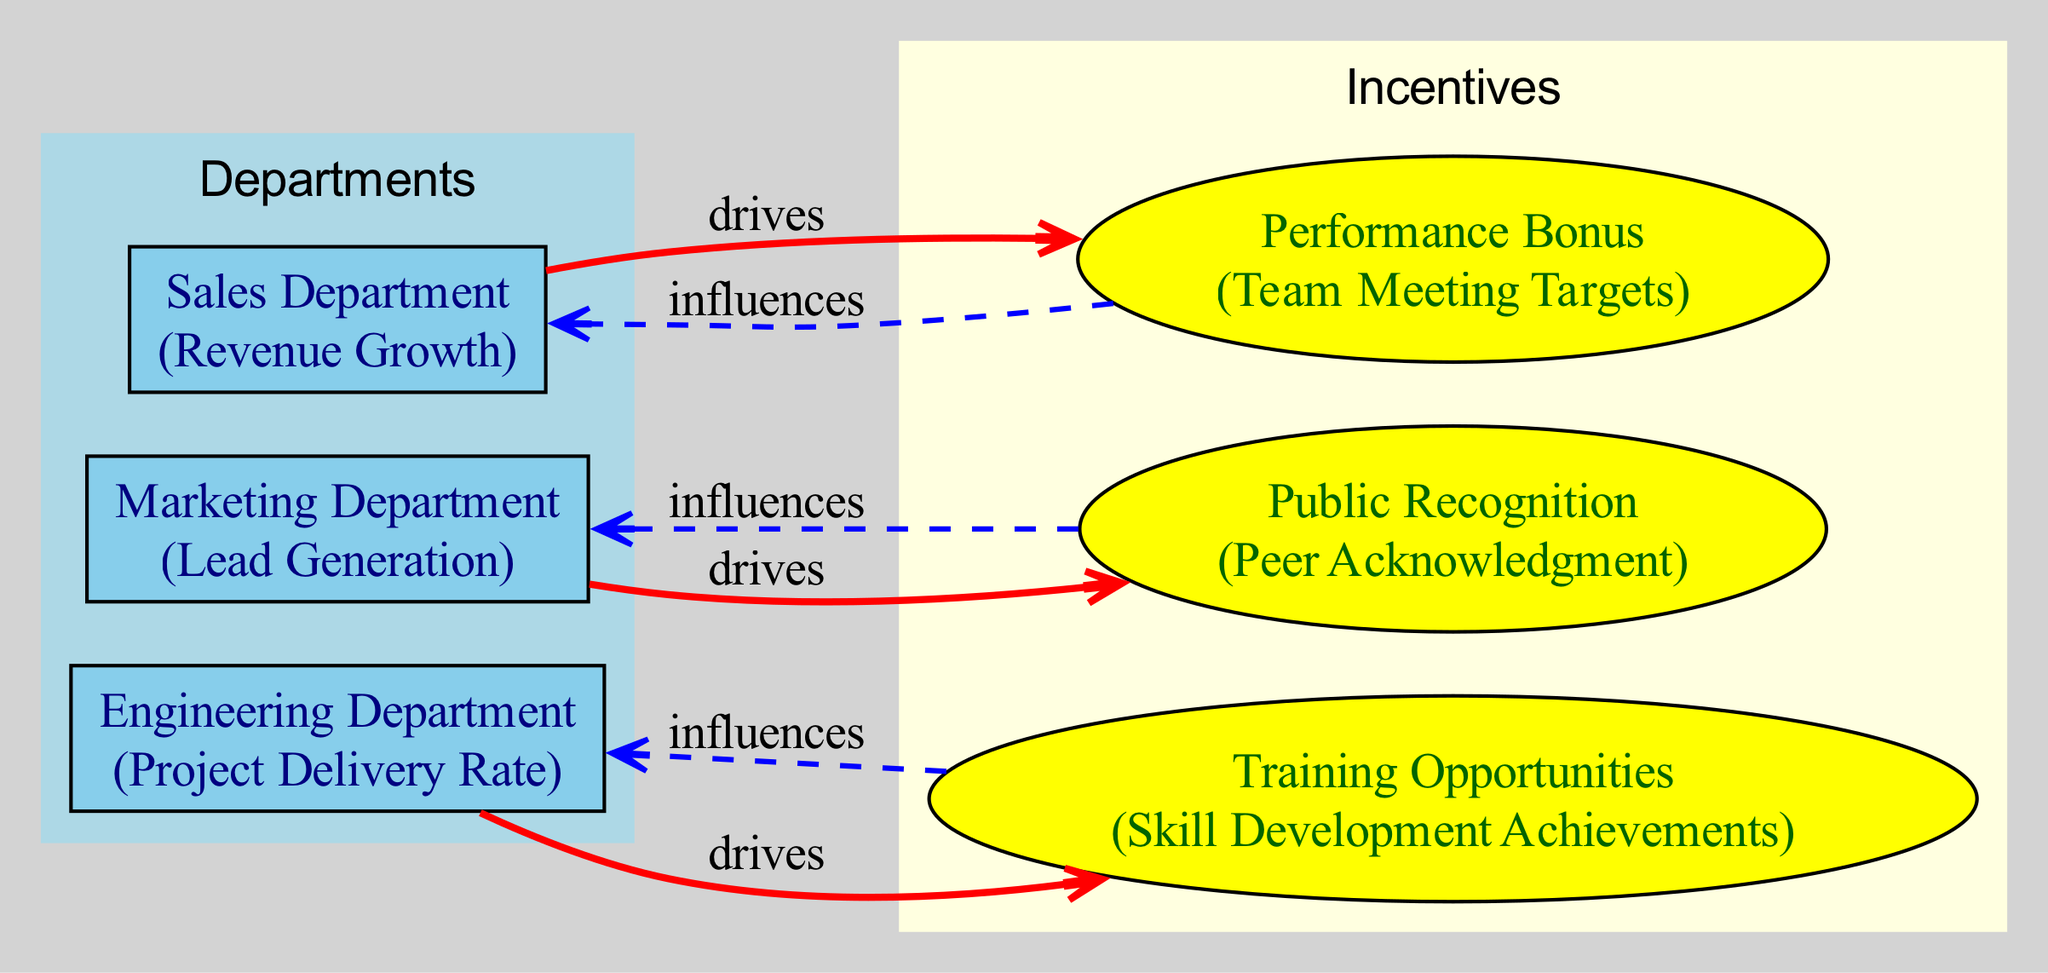What is the performance metric for the Sales Department? The Sales Department's performance metric is Revenue Growth, as indicated in the label for that node in the diagram.
Answer: Revenue Growth Which incentive is linked to the Engineering Department? The Engineering Department is linked to the Training Opportunities incentive, which is shown as the direct flow from the Engineering Department to the Training node.
Answer: Training Opportunities How many departments are featured in the diagram? There are three departments displayed in the diagram: Sales Department, Engineering Department, and Marketing Department.
Answer: Three What type of relationship exists between the Marketing Department and Public Recognition? The relationship is described as 'drives', which signifies that the Marketing Department influences the allocation of Public Recognition incentives in order to achieve its performance objectives.
Answer: Drives Which department receives influence from Performance Bonus? The Performance Bonus influences the Sales Department, as shown by the directed edge connecting the two nodes with the influence relationship.
Answer: Sales Department What allocation metric is associated with Public Recognition? The allocation metric for Public Recognition is Peer Acknowledgment, as specified in the details of that node in the diagram.
Answer: Peer Acknowledgment How many edges are in the diagram? The diagram features six edges, depicting various relationships between departments and incentives, including both drives and influences.
Answer: Six Which incentive is associated with skill development achievements? The Training Opportunities incentive is associated with skill development achievements, which is clearly noted in the corresponding node's description.
Answer: Training Opportunities Which department does the Performance Bonus drive? The Performance Bonus drives the Sales Department, as indicated by the directed edge from Performance Bonus to Sales Department in the diagram.
Answer: Sales Department 